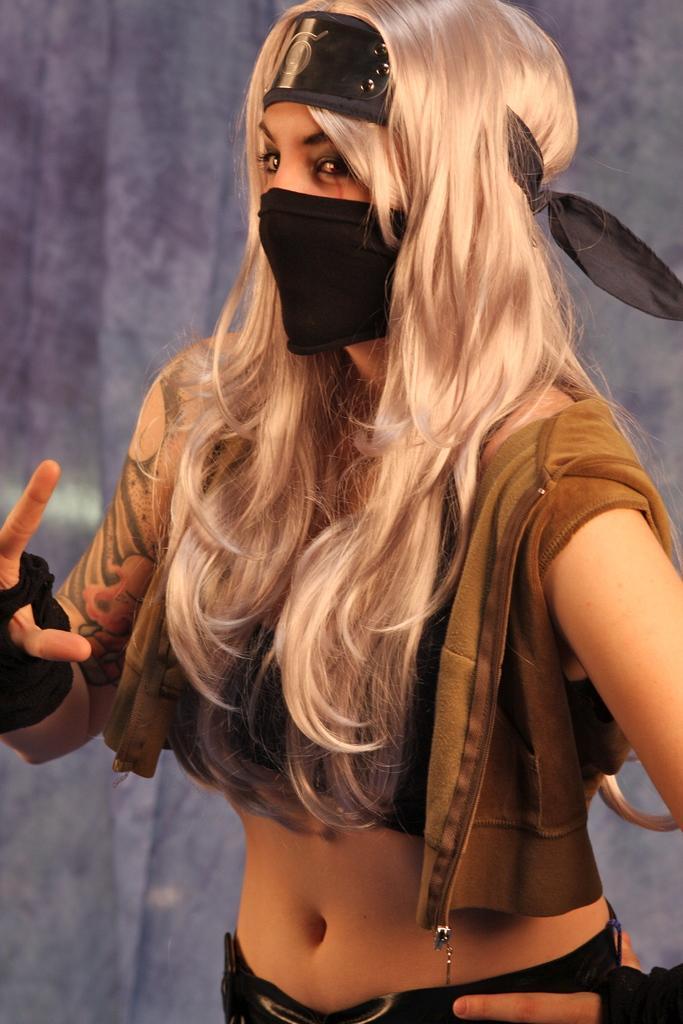Please provide a concise description of this image. Here in this picture we can see a woman standing over a place and she is wearing gloves and she is covering her mouth with a mask and behind her we can see a curtain present. 